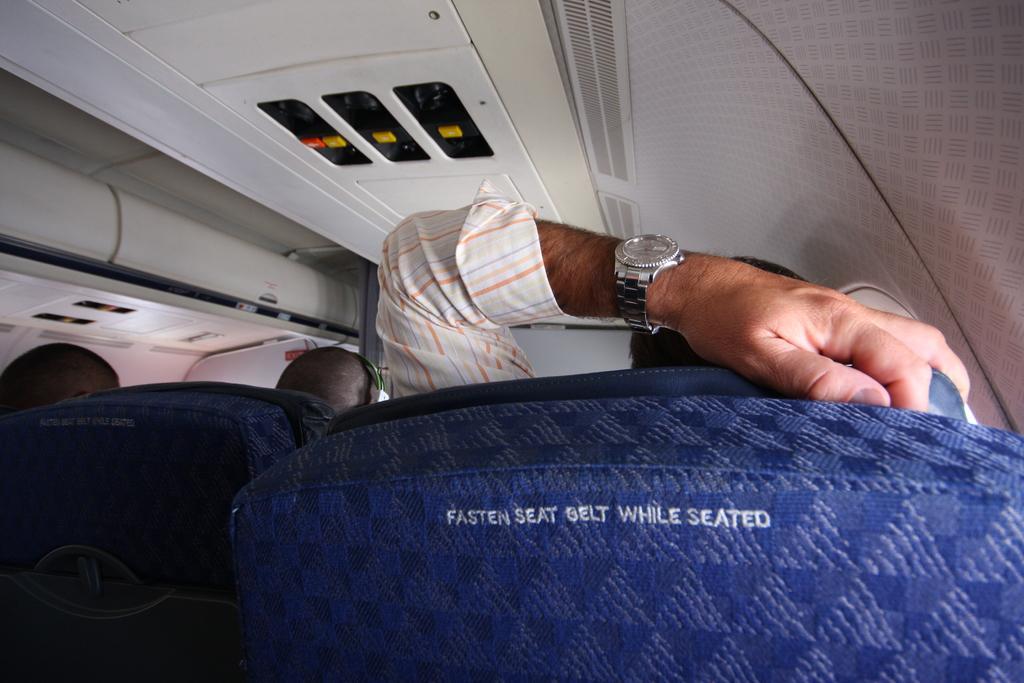Can you describe this image briefly? This image is taken inside a aeroplane. There are people sitting inside a aeroplane. 